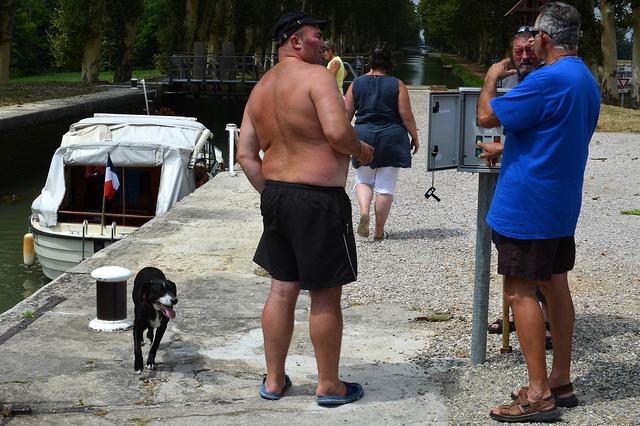What country does the flag on the boat represent?
Short answer required. Italy. Is the dog in motion?
Keep it brief. Yes. Is the weather cold?
Be succinct. No. Is the shirtless man overweight?
Answer briefly. Yes. 